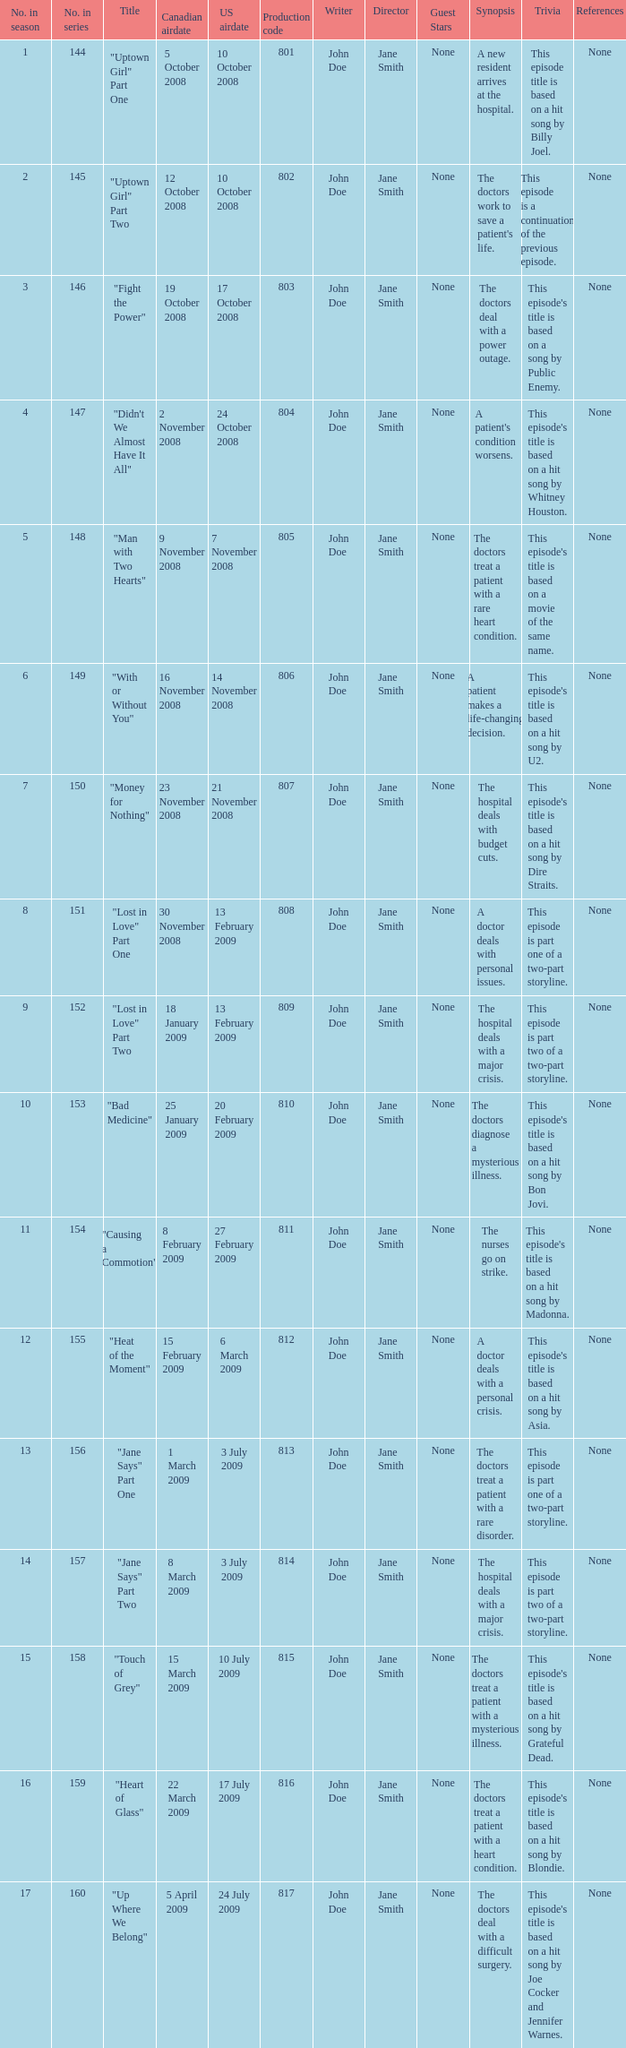What is the latest season number for a show with a production code of 816? 16.0. 